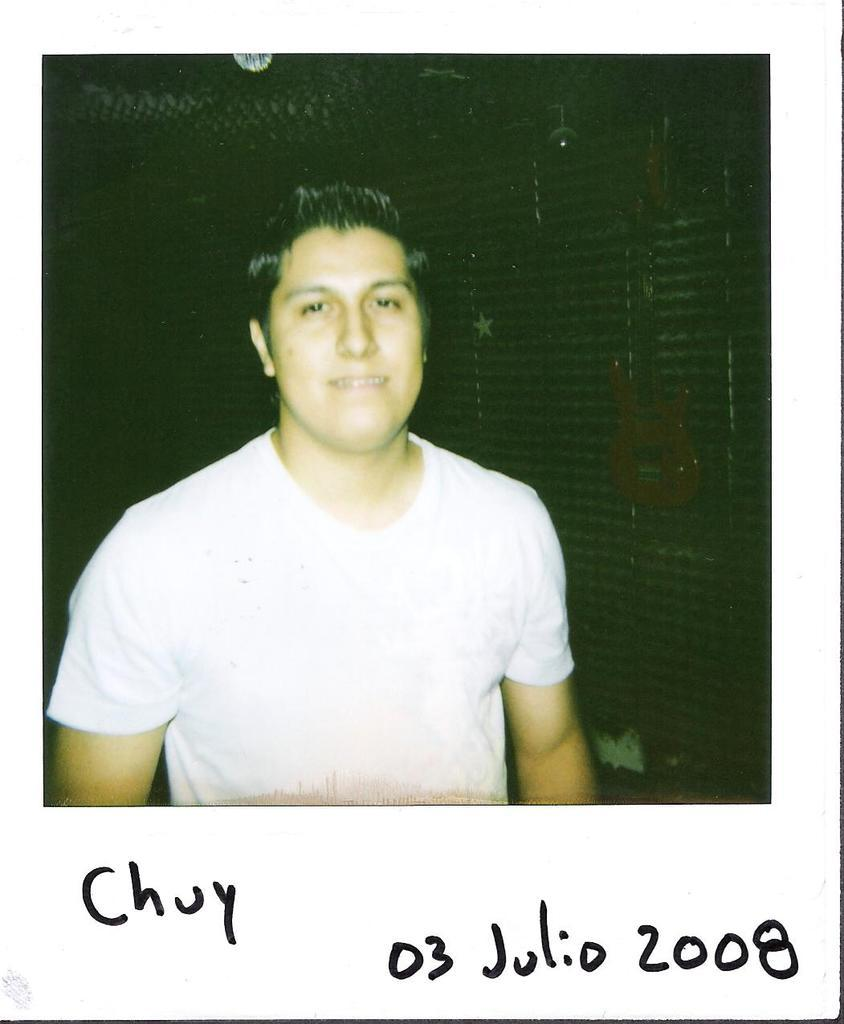What is the main subject in the foreground of the image? There is a man in the foreground of the image. What can be seen in the background of the image? There is a wall and lamps in the background of the image. How is the image presented? The image appears to be a photo frame. Is there any text present in the image? Yes, there is text present in the image. What is the chance of the lamps smashing during a protest in the image? There is no protest present in the image, and therefore no chance of the lamps smashing. 